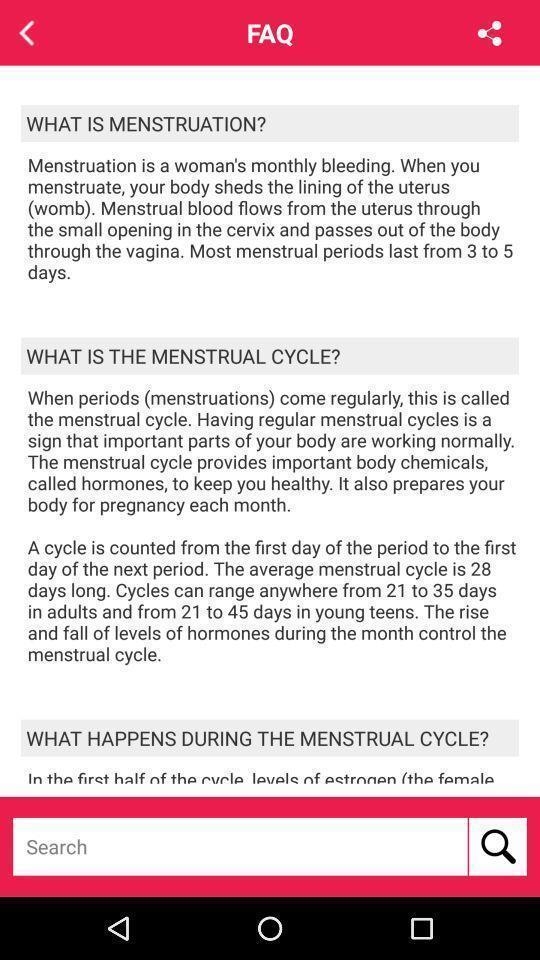Tell me about the visual elements in this screen capture. Page showing answers for the faq 's. 